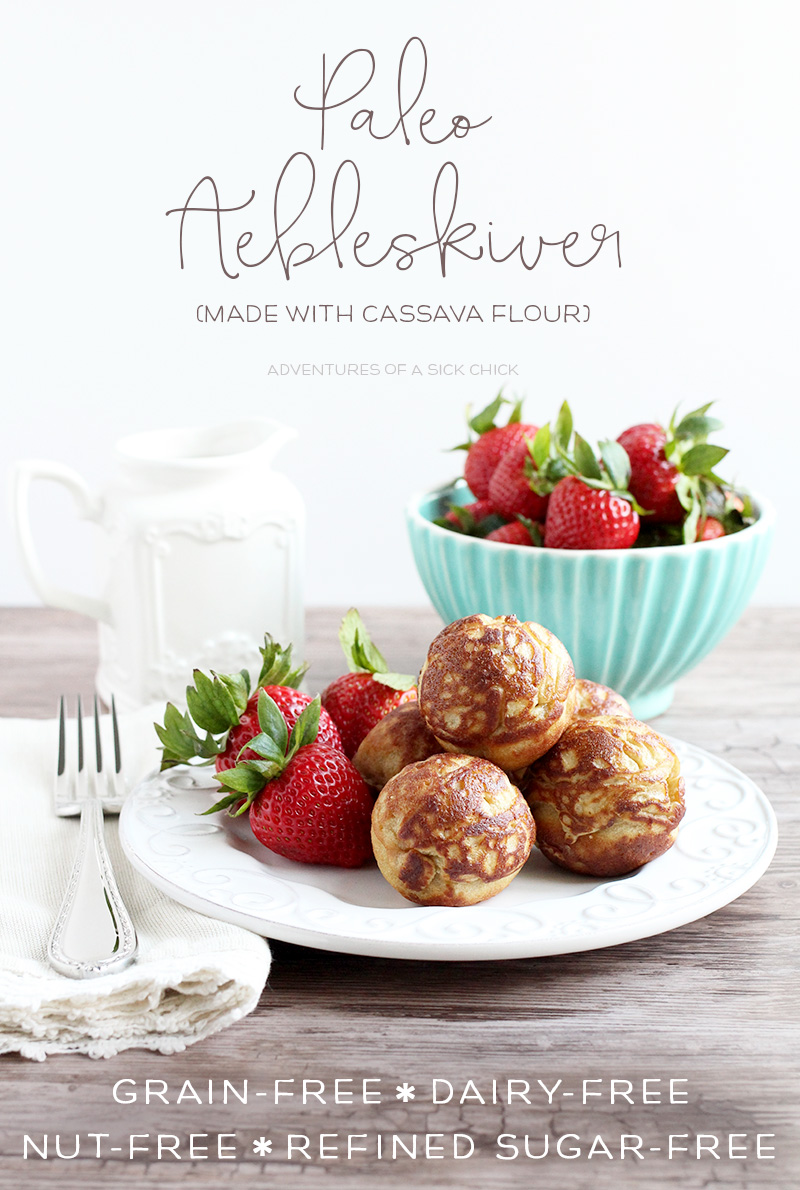Considering the health-focused nature of the food presented, what might be the purpose of choosing cassava flour over traditional wheat flour in the preparation of these pastries? The purpose of using cassava flour rather than traditional wheat flour in these pastries is to cater to various dietary requirements and health preferences. Cassava flour is a popular choice for those following a grain-free, gluten-free, and Paleo diet, which often avoids grains, dairy, and refined sugars. This aligns perfectly with the health attributes emphasized in the image, such as the pastries being ‘grain-free,’ ‘dairy-free,’ ‘nut-free,’ and ‘refined sugar-free.’ Additionally, cassava flour is known for its neutral taste and baking properties that closely mimic those of wheat flour, making it an excellent substitute without compromising on texture or flavor. This substitution is essential for individuals with gluten intolerances or allergies and those striving to maintain a healthier diet. 